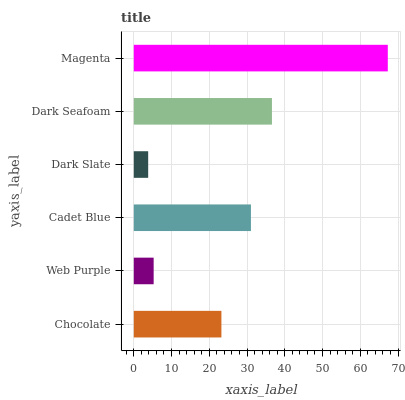Is Dark Slate the minimum?
Answer yes or no. Yes. Is Magenta the maximum?
Answer yes or no. Yes. Is Web Purple the minimum?
Answer yes or no. No. Is Web Purple the maximum?
Answer yes or no. No. Is Chocolate greater than Web Purple?
Answer yes or no. Yes. Is Web Purple less than Chocolate?
Answer yes or no. Yes. Is Web Purple greater than Chocolate?
Answer yes or no. No. Is Chocolate less than Web Purple?
Answer yes or no. No. Is Cadet Blue the high median?
Answer yes or no. Yes. Is Chocolate the low median?
Answer yes or no. Yes. Is Dark Slate the high median?
Answer yes or no. No. Is Dark Slate the low median?
Answer yes or no. No. 